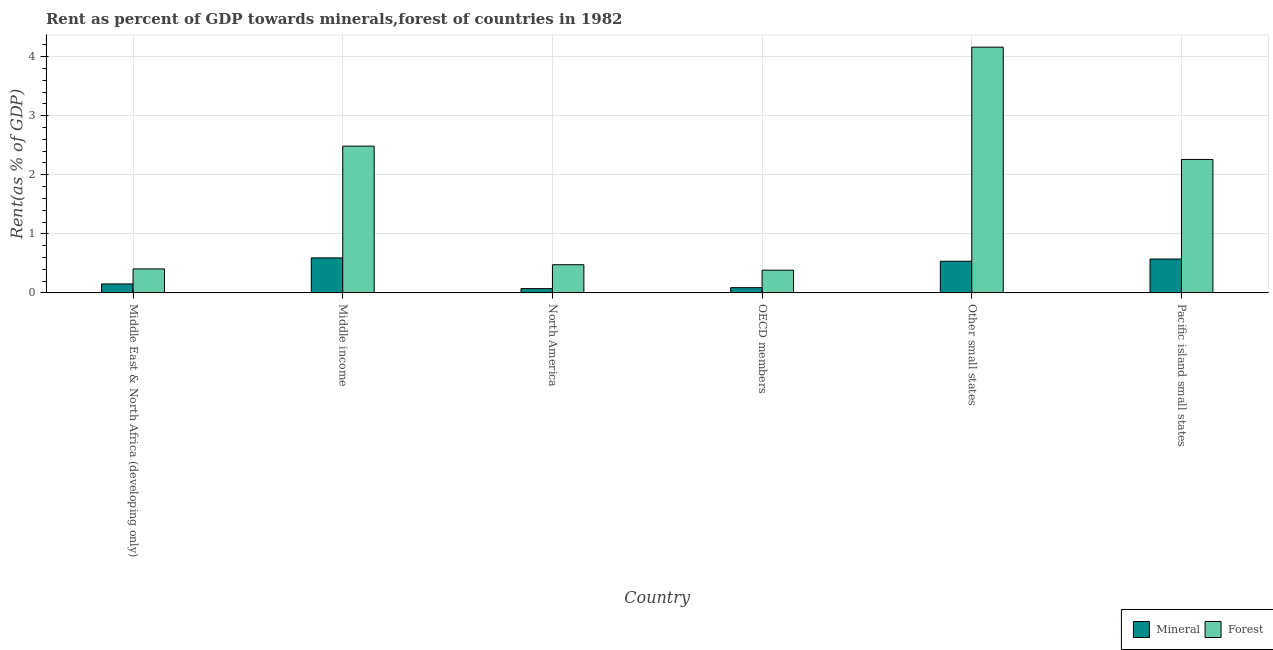How many different coloured bars are there?
Your response must be concise. 2. How many bars are there on the 3rd tick from the left?
Your answer should be compact. 2. How many bars are there on the 1st tick from the right?
Your answer should be very brief. 2. What is the label of the 1st group of bars from the left?
Offer a very short reply. Middle East & North Africa (developing only). What is the forest rent in Middle income?
Ensure brevity in your answer.  2.49. Across all countries, what is the maximum forest rent?
Make the answer very short. 4.16. Across all countries, what is the minimum mineral rent?
Provide a short and direct response. 0.07. In which country was the mineral rent maximum?
Your answer should be very brief. Middle income. What is the total mineral rent in the graph?
Give a very brief answer. 2.02. What is the difference between the mineral rent in Middle East & North Africa (developing only) and that in OECD members?
Your response must be concise. 0.06. What is the difference between the forest rent in Middle East & North Africa (developing only) and the mineral rent in North America?
Offer a very short reply. 0.33. What is the average forest rent per country?
Keep it short and to the point. 1.7. What is the difference between the forest rent and mineral rent in Other small states?
Make the answer very short. 3.62. In how many countries, is the mineral rent greater than 1.2 %?
Your response must be concise. 0. What is the ratio of the mineral rent in Middle income to that in OECD members?
Ensure brevity in your answer.  6.65. Is the forest rent in Middle income less than that in Other small states?
Offer a terse response. Yes. What is the difference between the highest and the second highest mineral rent?
Offer a terse response. 0.02. What is the difference between the highest and the lowest mineral rent?
Your answer should be compact. 0.52. Is the sum of the forest rent in Other small states and Pacific island small states greater than the maximum mineral rent across all countries?
Make the answer very short. Yes. What does the 1st bar from the left in Middle income represents?
Provide a short and direct response. Mineral. What does the 1st bar from the right in Middle East & North Africa (developing only) represents?
Offer a terse response. Forest. How many bars are there?
Your answer should be compact. 12. Are all the bars in the graph horizontal?
Your answer should be compact. No. What is the difference between two consecutive major ticks on the Y-axis?
Your response must be concise. 1. Are the values on the major ticks of Y-axis written in scientific E-notation?
Your answer should be very brief. No. Does the graph contain grids?
Provide a short and direct response. Yes. Where does the legend appear in the graph?
Ensure brevity in your answer.  Bottom right. How many legend labels are there?
Provide a succinct answer. 2. How are the legend labels stacked?
Offer a terse response. Horizontal. What is the title of the graph?
Your answer should be compact. Rent as percent of GDP towards minerals,forest of countries in 1982. What is the label or title of the X-axis?
Provide a succinct answer. Country. What is the label or title of the Y-axis?
Give a very brief answer. Rent(as % of GDP). What is the Rent(as % of GDP) in Mineral in Middle East & North Africa (developing only)?
Ensure brevity in your answer.  0.15. What is the Rent(as % of GDP) in Forest in Middle East & North Africa (developing only)?
Keep it short and to the point. 0.41. What is the Rent(as % of GDP) of Mineral in Middle income?
Your answer should be very brief. 0.59. What is the Rent(as % of GDP) of Forest in Middle income?
Your answer should be compact. 2.49. What is the Rent(as % of GDP) in Mineral in North America?
Keep it short and to the point. 0.07. What is the Rent(as % of GDP) of Forest in North America?
Your answer should be very brief. 0.48. What is the Rent(as % of GDP) in Mineral in OECD members?
Give a very brief answer. 0.09. What is the Rent(as % of GDP) of Forest in OECD members?
Your answer should be very brief. 0.39. What is the Rent(as % of GDP) of Mineral in Other small states?
Offer a very short reply. 0.54. What is the Rent(as % of GDP) of Forest in Other small states?
Ensure brevity in your answer.  4.16. What is the Rent(as % of GDP) of Mineral in Pacific island small states?
Your answer should be compact. 0.57. What is the Rent(as % of GDP) in Forest in Pacific island small states?
Give a very brief answer. 2.26. Across all countries, what is the maximum Rent(as % of GDP) in Mineral?
Provide a succinct answer. 0.59. Across all countries, what is the maximum Rent(as % of GDP) of Forest?
Your answer should be compact. 4.16. Across all countries, what is the minimum Rent(as % of GDP) of Mineral?
Offer a terse response. 0.07. Across all countries, what is the minimum Rent(as % of GDP) of Forest?
Provide a succinct answer. 0.39. What is the total Rent(as % of GDP) of Mineral in the graph?
Offer a terse response. 2.02. What is the total Rent(as % of GDP) of Forest in the graph?
Your answer should be very brief. 10.18. What is the difference between the Rent(as % of GDP) of Mineral in Middle East & North Africa (developing only) and that in Middle income?
Ensure brevity in your answer.  -0.44. What is the difference between the Rent(as % of GDP) of Forest in Middle East & North Africa (developing only) and that in Middle income?
Your answer should be very brief. -2.08. What is the difference between the Rent(as % of GDP) of Mineral in Middle East & North Africa (developing only) and that in North America?
Ensure brevity in your answer.  0.08. What is the difference between the Rent(as % of GDP) of Forest in Middle East & North Africa (developing only) and that in North America?
Give a very brief answer. -0.07. What is the difference between the Rent(as % of GDP) in Mineral in Middle East & North Africa (developing only) and that in OECD members?
Offer a very short reply. 0.06. What is the difference between the Rent(as % of GDP) in Forest in Middle East & North Africa (developing only) and that in OECD members?
Ensure brevity in your answer.  0.02. What is the difference between the Rent(as % of GDP) in Mineral in Middle East & North Africa (developing only) and that in Other small states?
Give a very brief answer. -0.38. What is the difference between the Rent(as % of GDP) of Forest in Middle East & North Africa (developing only) and that in Other small states?
Your answer should be compact. -3.75. What is the difference between the Rent(as % of GDP) of Mineral in Middle East & North Africa (developing only) and that in Pacific island small states?
Your response must be concise. -0.42. What is the difference between the Rent(as % of GDP) in Forest in Middle East & North Africa (developing only) and that in Pacific island small states?
Provide a succinct answer. -1.85. What is the difference between the Rent(as % of GDP) of Mineral in Middle income and that in North America?
Your response must be concise. 0.52. What is the difference between the Rent(as % of GDP) of Forest in Middle income and that in North America?
Make the answer very short. 2.01. What is the difference between the Rent(as % of GDP) of Mineral in Middle income and that in OECD members?
Provide a succinct answer. 0.5. What is the difference between the Rent(as % of GDP) of Forest in Middle income and that in OECD members?
Offer a very short reply. 2.1. What is the difference between the Rent(as % of GDP) of Mineral in Middle income and that in Other small states?
Ensure brevity in your answer.  0.06. What is the difference between the Rent(as % of GDP) of Forest in Middle income and that in Other small states?
Your answer should be compact. -1.68. What is the difference between the Rent(as % of GDP) of Mineral in Middle income and that in Pacific island small states?
Your response must be concise. 0.02. What is the difference between the Rent(as % of GDP) in Forest in Middle income and that in Pacific island small states?
Provide a succinct answer. 0.23. What is the difference between the Rent(as % of GDP) of Mineral in North America and that in OECD members?
Your response must be concise. -0.02. What is the difference between the Rent(as % of GDP) of Forest in North America and that in OECD members?
Provide a short and direct response. 0.09. What is the difference between the Rent(as % of GDP) of Mineral in North America and that in Other small states?
Your answer should be compact. -0.46. What is the difference between the Rent(as % of GDP) in Forest in North America and that in Other small states?
Offer a terse response. -3.68. What is the difference between the Rent(as % of GDP) of Mineral in North America and that in Pacific island small states?
Your answer should be compact. -0.5. What is the difference between the Rent(as % of GDP) of Forest in North America and that in Pacific island small states?
Ensure brevity in your answer.  -1.78. What is the difference between the Rent(as % of GDP) of Mineral in OECD members and that in Other small states?
Provide a short and direct response. -0.45. What is the difference between the Rent(as % of GDP) of Forest in OECD members and that in Other small states?
Your response must be concise. -3.78. What is the difference between the Rent(as % of GDP) of Mineral in OECD members and that in Pacific island small states?
Provide a succinct answer. -0.48. What is the difference between the Rent(as % of GDP) in Forest in OECD members and that in Pacific island small states?
Offer a terse response. -1.88. What is the difference between the Rent(as % of GDP) of Mineral in Other small states and that in Pacific island small states?
Your answer should be compact. -0.04. What is the difference between the Rent(as % of GDP) in Forest in Other small states and that in Pacific island small states?
Provide a succinct answer. 1.9. What is the difference between the Rent(as % of GDP) in Mineral in Middle East & North Africa (developing only) and the Rent(as % of GDP) in Forest in Middle income?
Keep it short and to the point. -2.33. What is the difference between the Rent(as % of GDP) of Mineral in Middle East & North Africa (developing only) and the Rent(as % of GDP) of Forest in North America?
Provide a succinct answer. -0.33. What is the difference between the Rent(as % of GDP) of Mineral in Middle East & North Africa (developing only) and the Rent(as % of GDP) of Forest in OECD members?
Give a very brief answer. -0.23. What is the difference between the Rent(as % of GDP) of Mineral in Middle East & North Africa (developing only) and the Rent(as % of GDP) of Forest in Other small states?
Your answer should be very brief. -4.01. What is the difference between the Rent(as % of GDP) of Mineral in Middle East & North Africa (developing only) and the Rent(as % of GDP) of Forest in Pacific island small states?
Give a very brief answer. -2.11. What is the difference between the Rent(as % of GDP) in Mineral in Middle income and the Rent(as % of GDP) in Forest in North America?
Keep it short and to the point. 0.12. What is the difference between the Rent(as % of GDP) of Mineral in Middle income and the Rent(as % of GDP) of Forest in OECD members?
Your answer should be very brief. 0.21. What is the difference between the Rent(as % of GDP) in Mineral in Middle income and the Rent(as % of GDP) in Forest in Other small states?
Provide a short and direct response. -3.57. What is the difference between the Rent(as % of GDP) in Mineral in Middle income and the Rent(as % of GDP) in Forest in Pacific island small states?
Offer a terse response. -1.67. What is the difference between the Rent(as % of GDP) in Mineral in North America and the Rent(as % of GDP) in Forest in OECD members?
Provide a short and direct response. -0.31. What is the difference between the Rent(as % of GDP) in Mineral in North America and the Rent(as % of GDP) in Forest in Other small states?
Offer a terse response. -4.09. What is the difference between the Rent(as % of GDP) in Mineral in North America and the Rent(as % of GDP) in Forest in Pacific island small states?
Make the answer very short. -2.19. What is the difference between the Rent(as % of GDP) in Mineral in OECD members and the Rent(as % of GDP) in Forest in Other small states?
Ensure brevity in your answer.  -4.07. What is the difference between the Rent(as % of GDP) in Mineral in OECD members and the Rent(as % of GDP) in Forest in Pacific island small states?
Give a very brief answer. -2.17. What is the difference between the Rent(as % of GDP) of Mineral in Other small states and the Rent(as % of GDP) of Forest in Pacific island small states?
Your response must be concise. -1.72. What is the average Rent(as % of GDP) of Mineral per country?
Provide a succinct answer. 0.34. What is the average Rent(as % of GDP) of Forest per country?
Your answer should be very brief. 1.7. What is the difference between the Rent(as % of GDP) of Mineral and Rent(as % of GDP) of Forest in Middle East & North Africa (developing only)?
Offer a terse response. -0.25. What is the difference between the Rent(as % of GDP) of Mineral and Rent(as % of GDP) of Forest in Middle income?
Offer a terse response. -1.89. What is the difference between the Rent(as % of GDP) in Mineral and Rent(as % of GDP) in Forest in North America?
Provide a short and direct response. -0.4. What is the difference between the Rent(as % of GDP) in Mineral and Rent(as % of GDP) in Forest in OECD members?
Give a very brief answer. -0.3. What is the difference between the Rent(as % of GDP) of Mineral and Rent(as % of GDP) of Forest in Other small states?
Provide a short and direct response. -3.62. What is the difference between the Rent(as % of GDP) in Mineral and Rent(as % of GDP) in Forest in Pacific island small states?
Keep it short and to the point. -1.69. What is the ratio of the Rent(as % of GDP) in Mineral in Middle East & North Africa (developing only) to that in Middle income?
Your answer should be very brief. 0.26. What is the ratio of the Rent(as % of GDP) of Forest in Middle East & North Africa (developing only) to that in Middle income?
Ensure brevity in your answer.  0.16. What is the ratio of the Rent(as % of GDP) of Mineral in Middle East & North Africa (developing only) to that in North America?
Make the answer very short. 2.09. What is the ratio of the Rent(as % of GDP) in Forest in Middle East & North Africa (developing only) to that in North America?
Ensure brevity in your answer.  0.85. What is the ratio of the Rent(as % of GDP) of Mineral in Middle East & North Africa (developing only) to that in OECD members?
Provide a succinct answer. 1.71. What is the ratio of the Rent(as % of GDP) in Forest in Middle East & North Africa (developing only) to that in OECD members?
Provide a succinct answer. 1.06. What is the ratio of the Rent(as % of GDP) in Mineral in Middle East & North Africa (developing only) to that in Other small states?
Ensure brevity in your answer.  0.28. What is the ratio of the Rent(as % of GDP) of Forest in Middle East & North Africa (developing only) to that in Other small states?
Your answer should be compact. 0.1. What is the ratio of the Rent(as % of GDP) in Mineral in Middle East & North Africa (developing only) to that in Pacific island small states?
Offer a very short reply. 0.27. What is the ratio of the Rent(as % of GDP) in Forest in Middle East & North Africa (developing only) to that in Pacific island small states?
Your response must be concise. 0.18. What is the ratio of the Rent(as % of GDP) in Mineral in Middle income to that in North America?
Your answer should be compact. 8.15. What is the ratio of the Rent(as % of GDP) of Forest in Middle income to that in North America?
Give a very brief answer. 5.2. What is the ratio of the Rent(as % of GDP) of Mineral in Middle income to that in OECD members?
Your answer should be very brief. 6.65. What is the ratio of the Rent(as % of GDP) of Forest in Middle income to that in OECD members?
Your response must be concise. 6.45. What is the ratio of the Rent(as % of GDP) in Mineral in Middle income to that in Other small states?
Ensure brevity in your answer.  1.11. What is the ratio of the Rent(as % of GDP) of Forest in Middle income to that in Other small states?
Ensure brevity in your answer.  0.6. What is the ratio of the Rent(as % of GDP) in Mineral in Middle income to that in Pacific island small states?
Give a very brief answer. 1.03. What is the ratio of the Rent(as % of GDP) in Forest in Middle income to that in Pacific island small states?
Keep it short and to the point. 1.1. What is the ratio of the Rent(as % of GDP) in Mineral in North America to that in OECD members?
Your answer should be compact. 0.82. What is the ratio of the Rent(as % of GDP) in Forest in North America to that in OECD members?
Provide a succinct answer. 1.24. What is the ratio of the Rent(as % of GDP) in Mineral in North America to that in Other small states?
Keep it short and to the point. 0.14. What is the ratio of the Rent(as % of GDP) in Forest in North America to that in Other small states?
Give a very brief answer. 0.11. What is the ratio of the Rent(as % of GDP) in Mineral in North America to that in Pacific island small states?
Offer a terse response. 0.13. What is the ratio of the Rent(as % of GDP) in Forest in North America to that in Pacific island small states?
Provide a succinct answer. 0.21. What is the ratio of the Rent(as % of GDP) in Mineral in OECD members to that in Other small states?
Your answer should be very brief. 0.17. What is the ratio of the Rent(as % of GDP) of Forest in OECD members to that in Other small states?
Your answer should be very brief. 0.09. What is the ratio of the Rent(as % of GDP) of Mineral in OECD members to that in Pacific island small states?
Your answer should be very brief. 0.16. What is the ratio of the Rent(as % of GDP) in Forest in OECD members to that in Pacific island small states?
Give a very brief answer. 0.17. What is the ratio of the Rent(as % of GDP) in Mineral in Other small states to that in Pacific island small states?
Provide a succinct answer. 0.93. What is the ratio of the Rent(as % of GDP) of Forest in Other small states to that in Pacific island small states?
Ensure brevity in your answer.  1.84. What is the difference between the highest and the second highest Rent(as % of GDP) in Mineral?
Provide a short and direct response. 0.02. What is the difference between the highest and the second highest Rent(as % of GDP) of Forest?
Make the answer very short. 1.68. What is the difference between the highest and the lowest Rent(as % of GDP) in Mineral?
Give a very brief answer. 0.52. What is the difference between the highest and the lowest Rent(as % of GDP) in Forest?
Give a very brief answer. 3.78. 